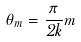<formula> <loc_0><loc_0><loc_500><loc_500>\theta _ { m } = \frac { \pi } { 2 k } m</formula> 